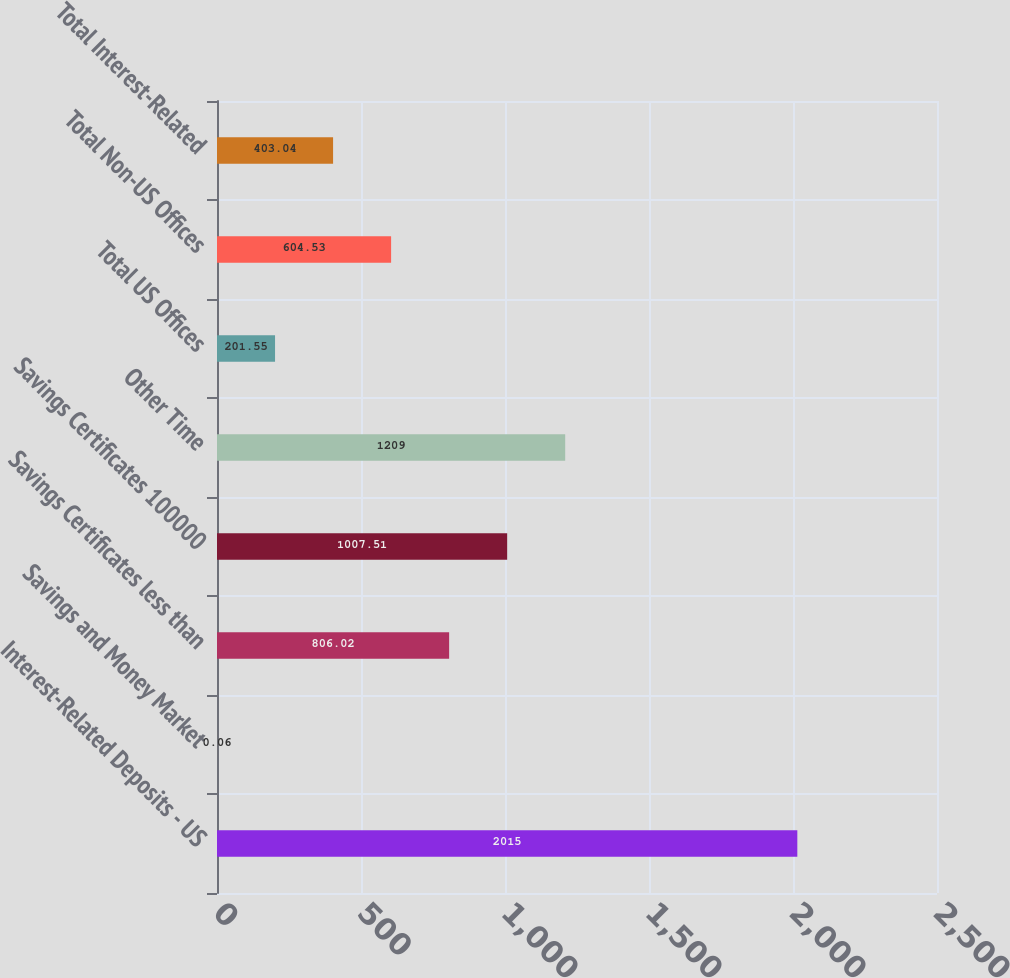Convert chart. <chart><loc_0><loc_0><loc_500><loc_500><bar_chart><fcel>Interest-Related Deposits - US<fcel>Savings and Money Market<fcel>Savings Certificates less than<fcel>Savings Certificates 100000<fcel>Other Time<fcel>Total US Offices<fcel>Total Non-US Offices<fcel>Total Interest-Related<nl><fcel>2015<fcel>0.06<fcel>806.02<fcel>1007.51<fcel>1209<fcel>201.55<fcel>604.53<fcel>403.04<nl></chart> 